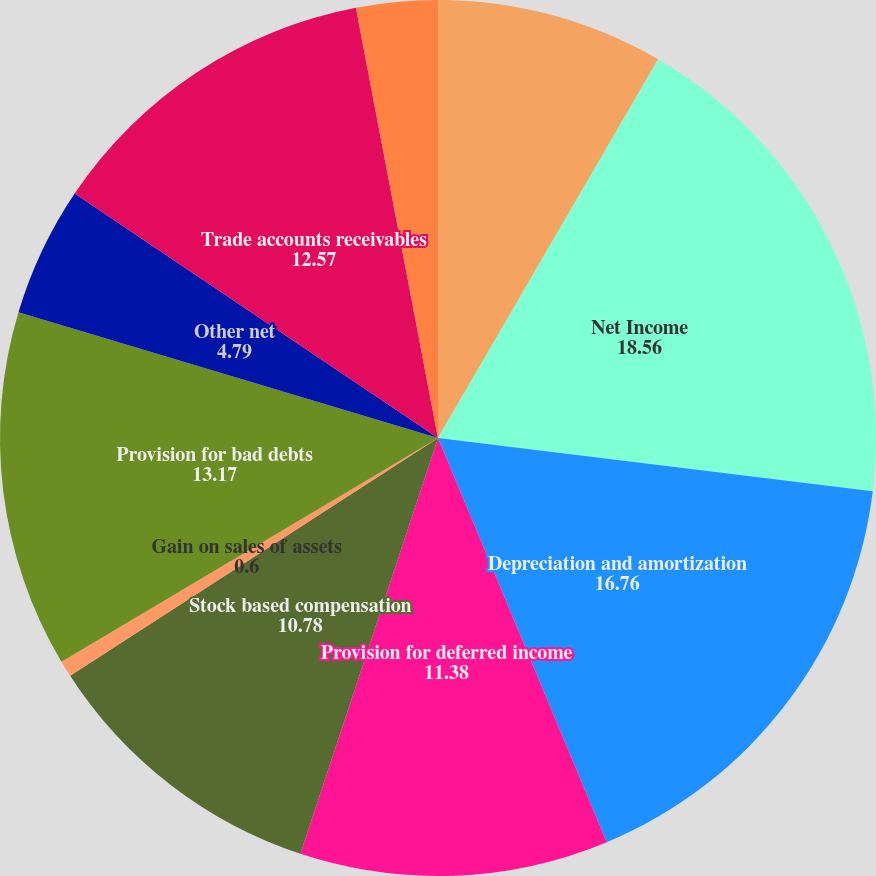<chart> <loc_0><loc_0><loc_500><loc_500><pie_chart><fcel>Years ended December 31 (in<fcel>Net Income<fcel>Depreciation and amortization<fcel>Provision for deferred income<fcel>Stock based compensation<fcel>Gain on sales of assets<fcel>Provision for bad debts<fcel>Other net<fcel>Trade accounts receivables<fcel>Accounts receivable-other<nl><fcel>8.38%<fcel>18.56%<fcel>16.76%<fcel>11.38%<fcel>10.78%<fcel>0.6%<fcel>13.17%<fcel>4.79%<fcel>12.57%<fcel>3.0%<nl></chart> 